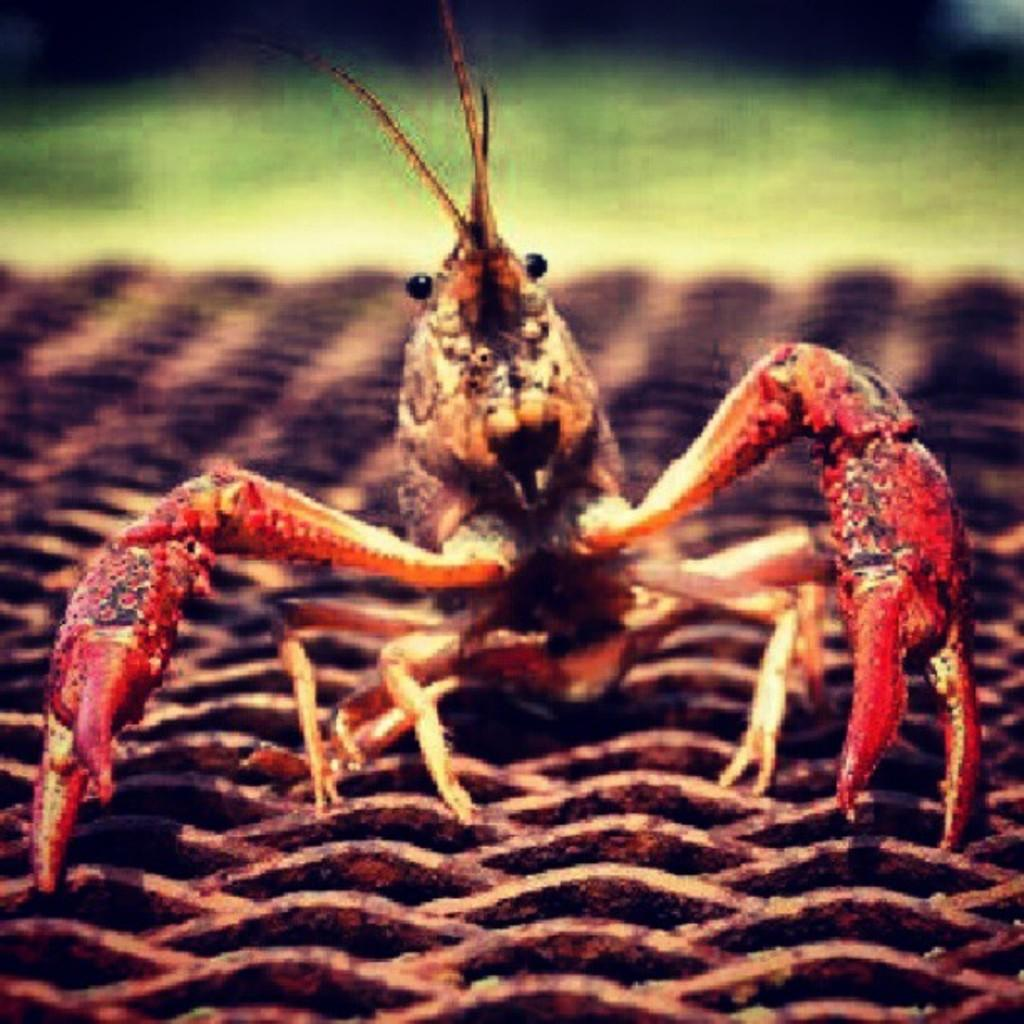What type of animal is in the image? There is a crab in the image. What color is the crab? The crab is light green in color. What is the background of the image? There is a black background in the image. What type of competition is taking place in the image? There is no competition present in the image; it features a light green crab against a black background. Can you tell me how many plants are visible in the image? There are no plants visible in the image; it features a light green crab against a black background. 